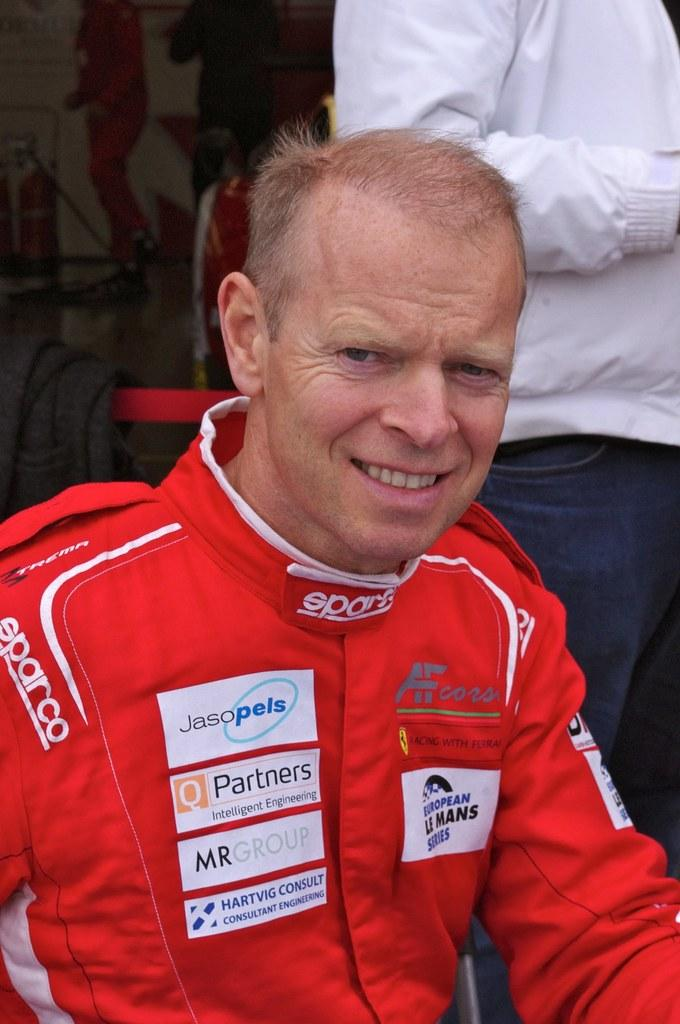<image>
Give a short and clear explanation of the subsequent image. European Le Mans Series reads the patch on this driver's uniform. 